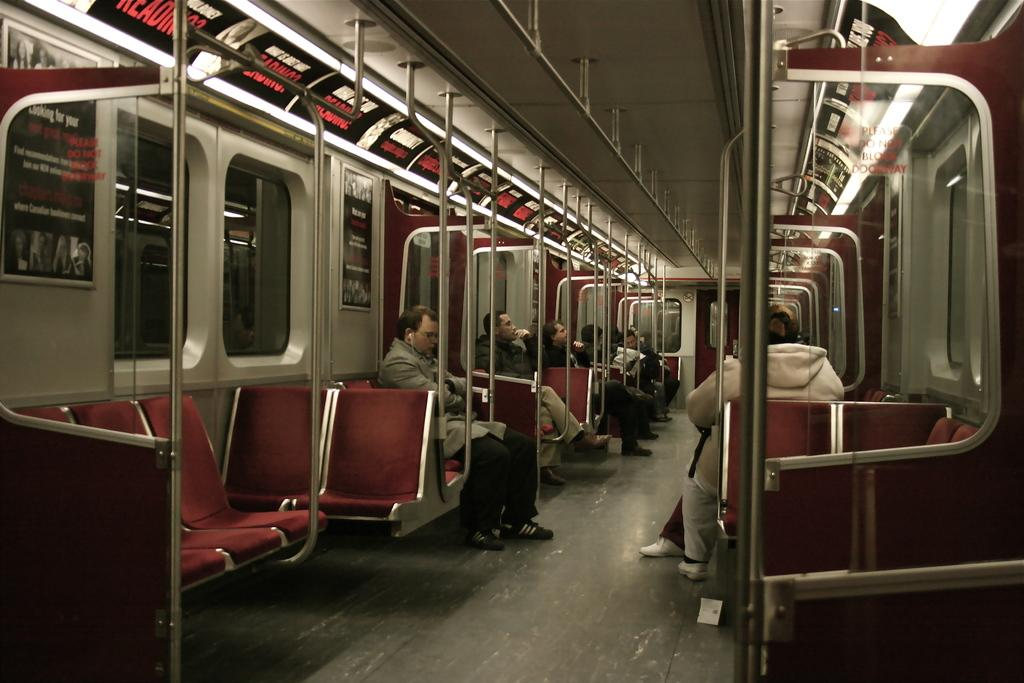Who or what can be seen in the image? There are people in the image. What are the people doing in the image? The people are sitting on the seats of a locomotive. What type of finger can be seen in the image? There is no finger present in the image. Where is the cemetery located in the image? There is no cemetery present in the image. 